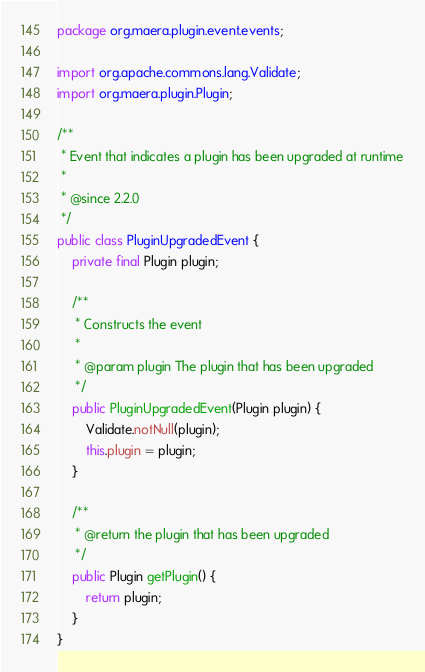<code> <loc_0><loc_0><loc_500><loc_500><_Java_>package org.maera.plugin.event.events;

import org.apache.commons.lang.Validate;
import org.maera.plugin.Plugin;

/**
 * Event that indicates a plugin has been upgraded at runtime
 *
 * @since 2.2.0
 */
public class PluginUpgradedEvent {
    private final Plugin plugin;

    /**
     * Constructs the event
     *
     * @param plugin The plugin that has been upgraded
     */
    public PluginUpgradedEvent(Plugin plugin) {
        Validate.notNull(plugin);
        this.plugin = plugin;
    }

    /**
     * @return the plugin that has been upgraded
     */
    public Plugin getPlugin() {
        return plugin;
    }
}
</code> 